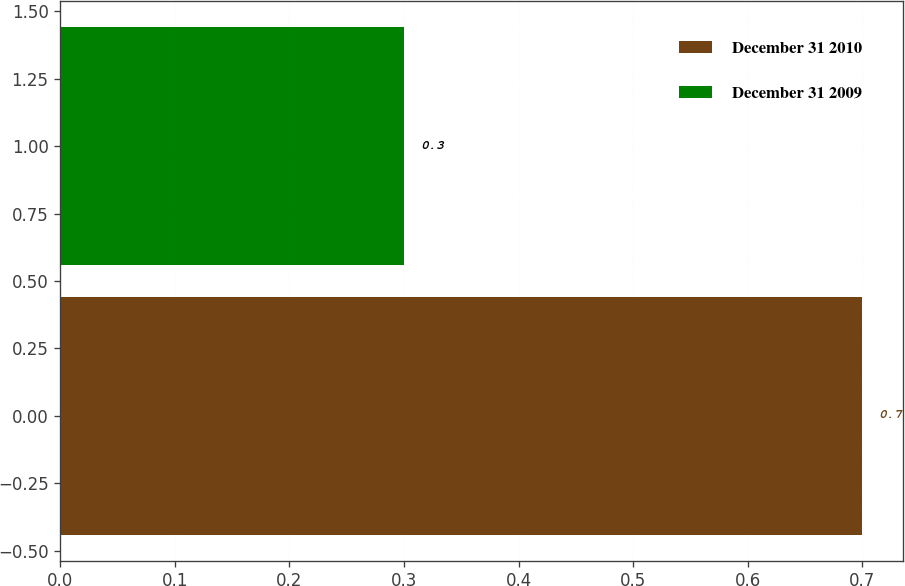<chart> <loc_0><loc_0><loc_500><loc_500><bar_chart><fcel>December 31 2010<fcel>December 31 2009<nl><fcel>0.7<fcel>0.3<nl></chart> 